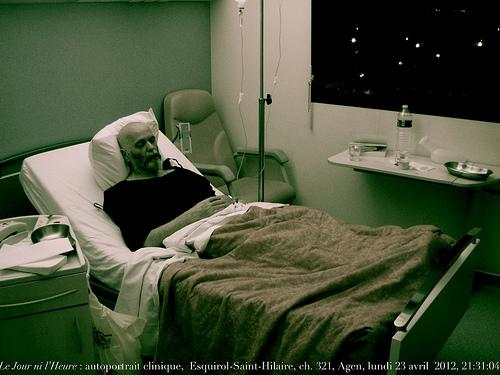Count the number of references related to the water bottle in the image data. 8 mentions related to the water bottle. In one sentence, describe the lighting condition of the room depicted in the image. Lights are shining outside the window, brightening the room from that source. Identify and describe an object in the image that pertains to medical care. The IV drip is a medical equipment attached to the sickly man, providing continuous administration of fluids or medication. What type of room does this image seem to be set in? A hospital room. Provide a brief description of the primary scene in the image. A man is laying in a hospital bed, surrounded by various items such as an IV drip, a plastic water bottle, a metal bed pan, and a white phone on a rolling cart. How many distinct mentions of the man in the bed are there in the image data? 11 distinct mentions. Analyze the image sentiment and describe the overall atmosphere conveyed by it. The image sentiment is somber, as it portrays a very ill man lying in a hospital bed with medical equipment around him. What type of table is mentioned in the image's image data? A small white table by the wall. Name three objects you can find in the image. A hospital bed, a water bottle, and an IV drip pole. Describe the personal appearance of the man in the bed. The man has no hair on his head, has a white goatee, and hands are folded. Is there a purple chair with wheels in the corner of the room? A hospital chair and an empty chair in the corner are mentioned, but no information about the color or the presence of wheels are provided. Is there a yellow blanket covering the man in the bed? The captions mention a brown blanket or comforter, not a yellow one. Is the book on the counter blue and titled "The Great Adventure"? There is a mention of a book setting on the counter, but no information about the color or the title is provided. Are the walls of the hospital room decorated with paintings and posters? The captions mention white walls of the hospital room, but there is no information about any decorations like paintings or posters. Is the man wearing a red shirt in the bed? There is no mention of the color of the man's clothing, only that he is in a bed or hospital bed. Can you see a green water bottle on the shelf? The water bottle is described as a plastic water bottle, but its color is not mentioned. It could be any color, not necessarily green. 